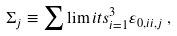Convert formula to latex. <formula><loc_0><loc_0><loc_500><loc_500>\Sigma _ { j } \equiv \sum \lim i t s _ { i = 1 } ^ { 3 } { \varepsilon _ { 0 , i i , j } } \, ,</formula> 